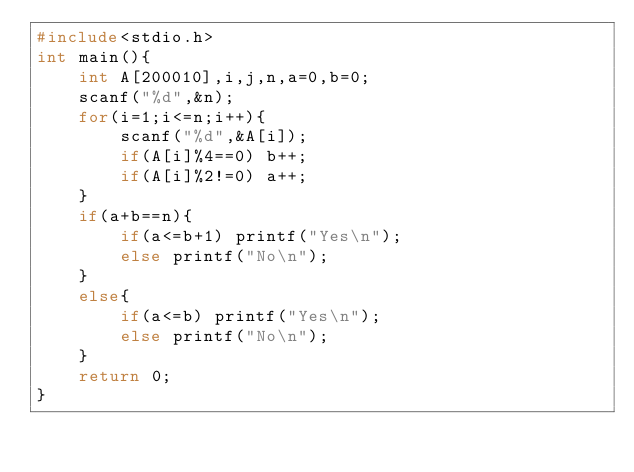<code> <loc_0><loc_0><loc_500><loc_500><_C_>#include<stdio.h>
int main(){
	int A[200010],i,j,n,a=0,b=0;
	scanf("%d",&n);
	for(i=1;i<=n;i++){
		scanf("%d",&A[i]);
		if(A[i]%4==0) b++;
		if(A[i]%2!=0) a++;
	}
	if(a+b==n){
		if(a<=b+1) printf("Yes\n");
		else printf("No\n");
	}
	else{
		if(a<=b) printf("Yes\n");
		else printf("No\n");
	}
	return 0;
}</code> 